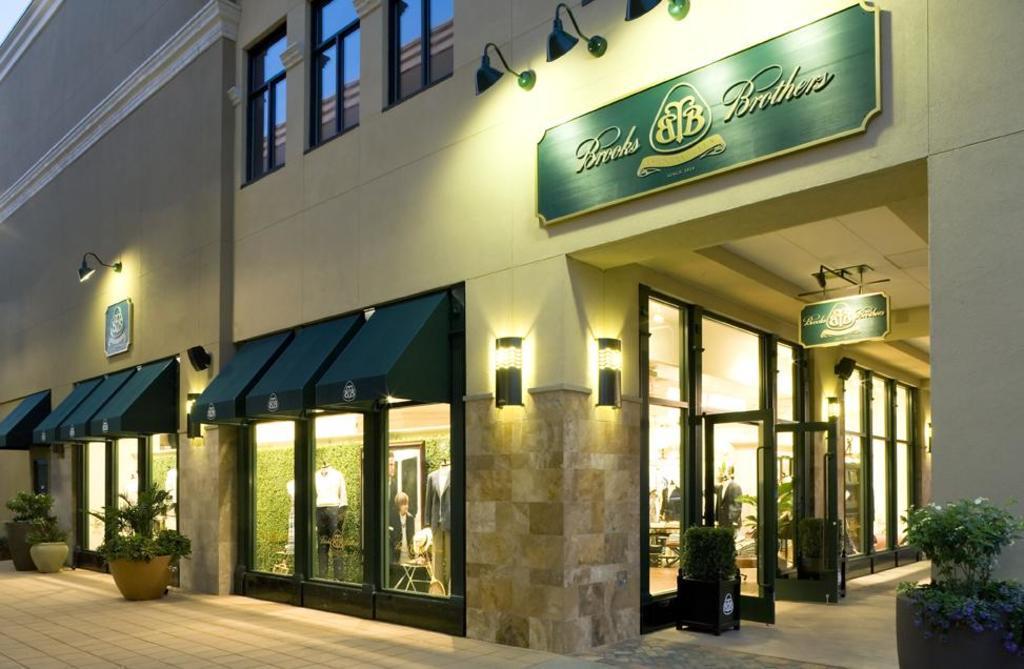Describe this image in one or two sentences. We can see building,wall,windows and glass,through this glass we can see people,through this glass windows we can see sky. We can see boards and plants. 